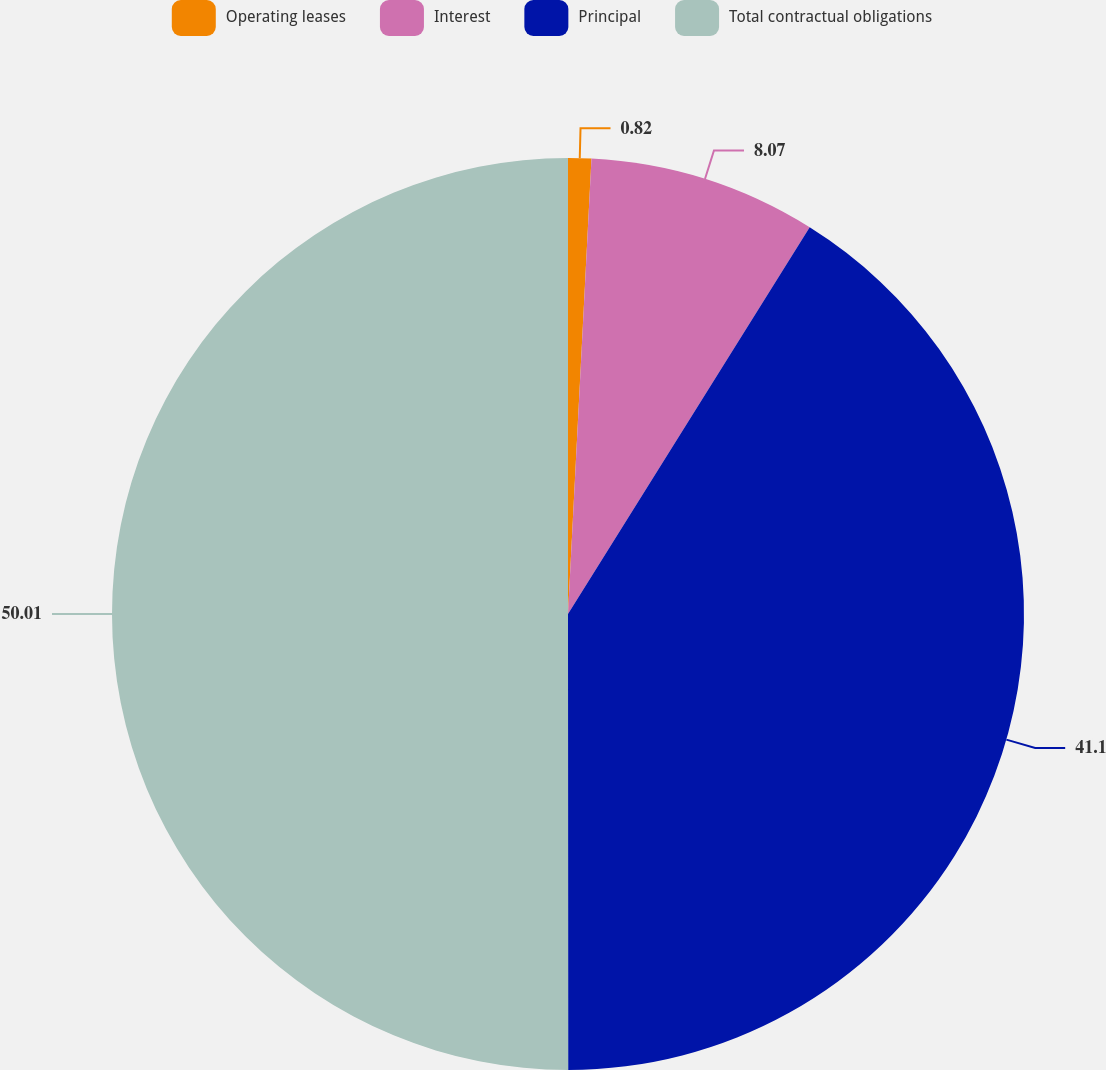Convert chart to OTSL. <chart><loc_0><loc_0><loc_500><loc_500><pie_chart><fcel>Operating leases<fcel>Interest<fcel>Principal<fcel>Total contractual obligations<nl><fcel>0.82%<fcel>8.07%<fcel>41.1%<fcel>50.0%<nl></chart> 